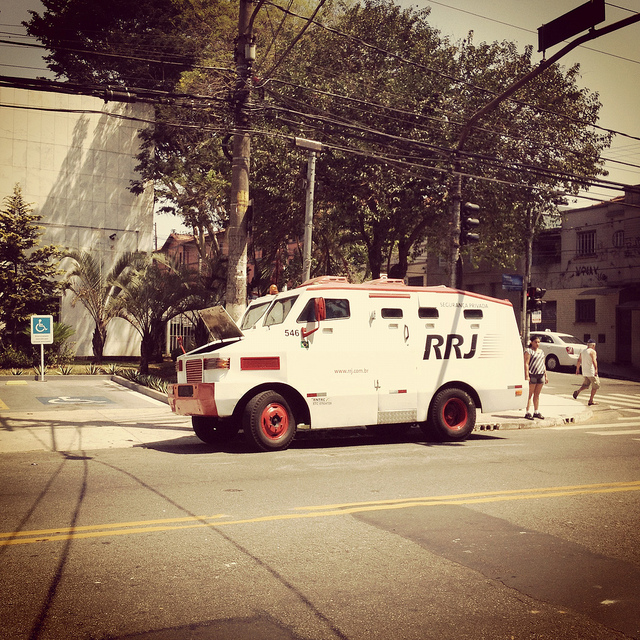Extract all visible text content from this image. 546 RRJ 